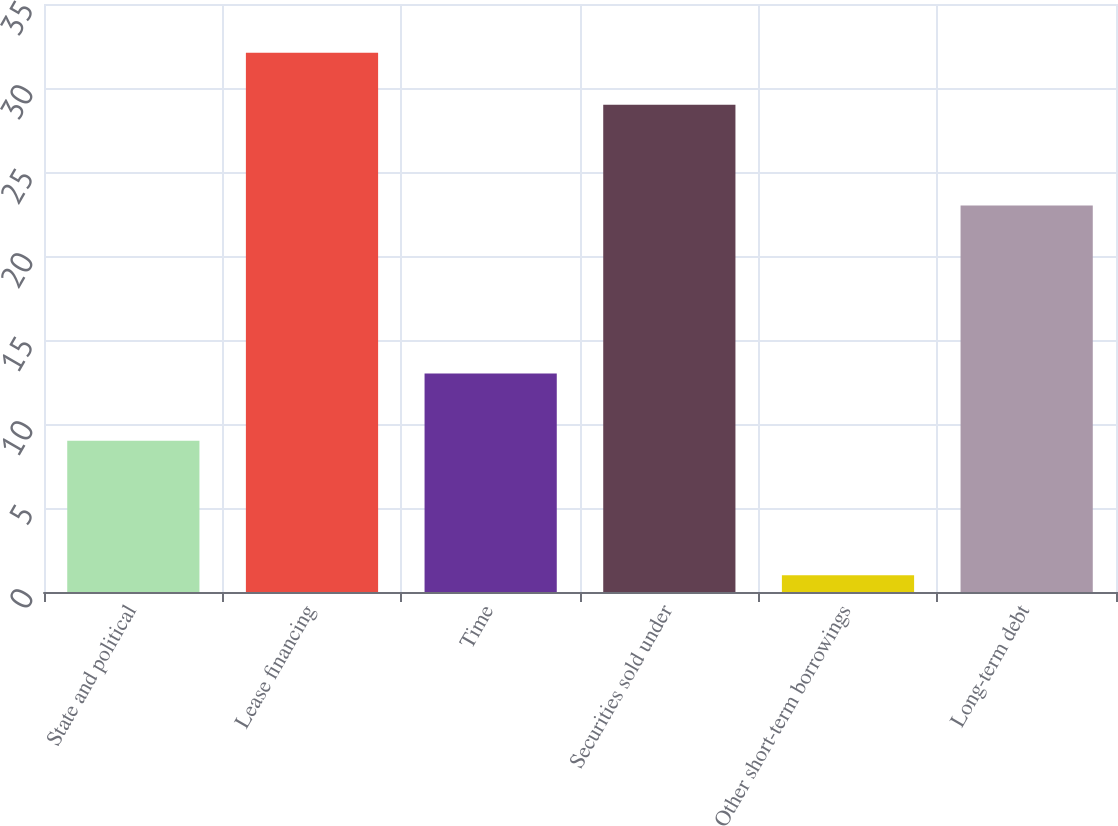Convert chart. <chart><loc_0><loc_0><loc_500><loc_500><bar_chart><fcel>State and political<fcel>Lease financing<fcel>Time<fcel>Securities sold under<fcel>Other short-term borrowings<fcel>Long-term debt<nl><fcel>9<fcel>32.1<fcel>13<fcel>29<fcel>1<fcel>23<nl></chart> 